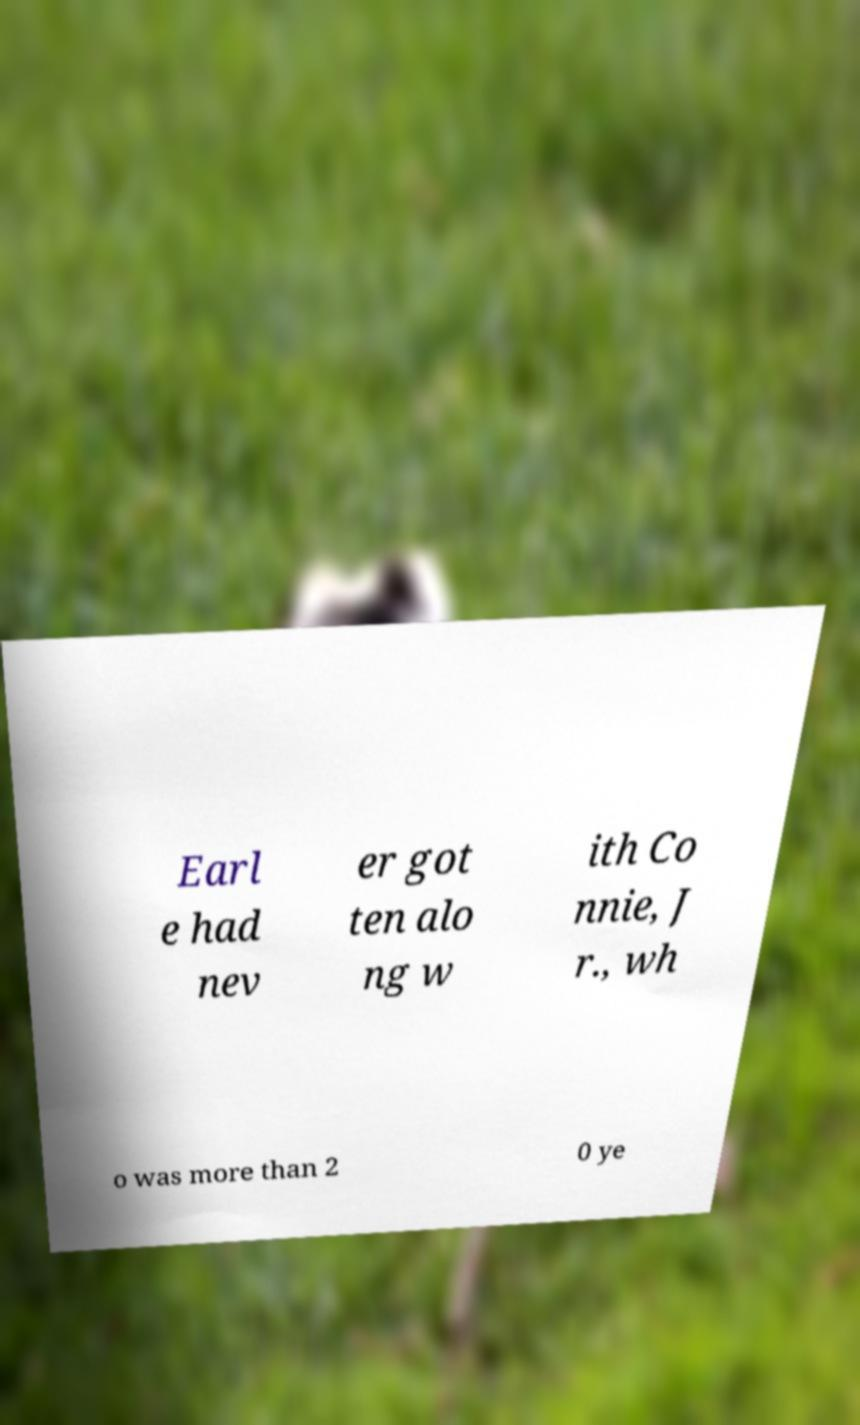There's text embedded in this image that I need extracted. Can you transcribe it verbatim? Earl e had nev er got ten alo ng w ith Co nnie, J r., wh o was more than 2 0 ye 